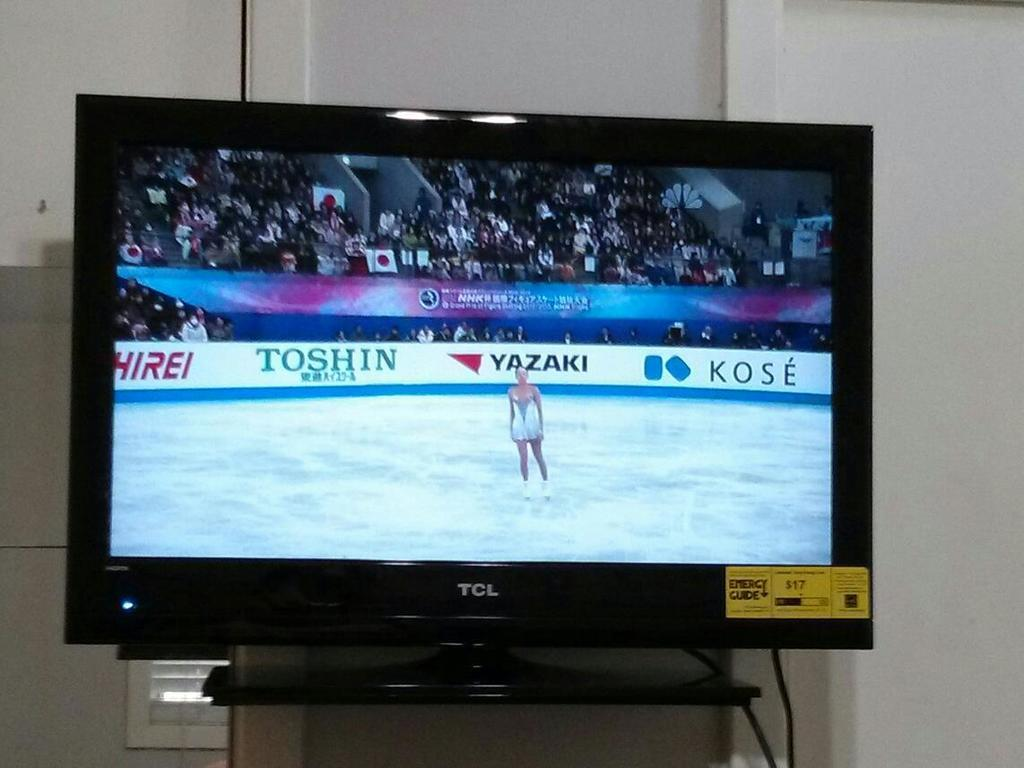<image>
Write a terse but informative summary of the picture. A TCL brand television displays an ice skater in mid-routine. 